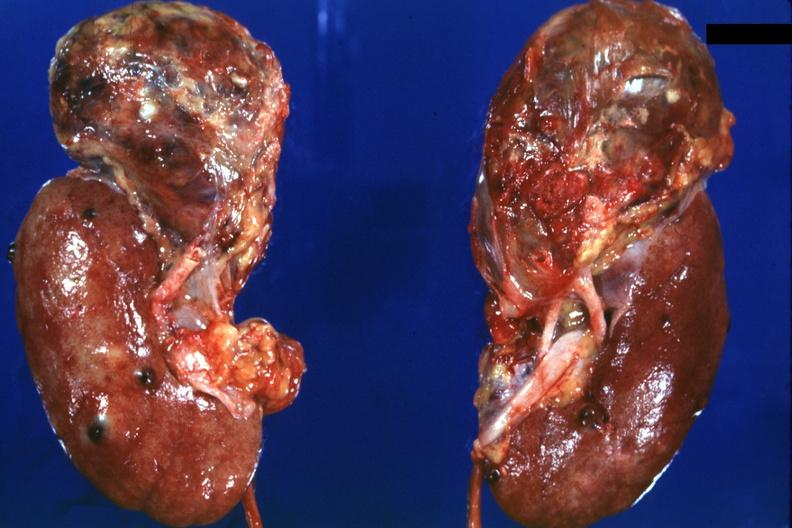s renal cell carcinoma present?
Answer the question using a single word or phrase. Yes 